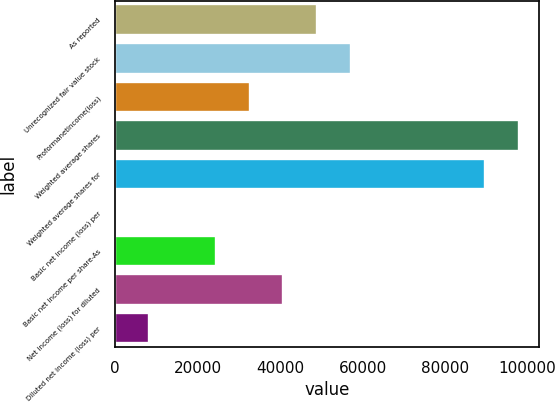Convert chart. <chart><loc_0><loc_0><loc_500><loc_500><bar_chart><fcel>As reported<fcel>Unrecognized fair value stock<fcel>Proformanetincome(loss)<fcel>Weighted average shares<fcel>Weighted average shares for<fcel>Basic net income (loss) per<fcel>Basic net income per share-As<fcel>Net income (loss) for diluted<fcel>Diluted net income (loss) per<nl><fcel>48955.8<fcel>57115.1<fcel>32637.2<fcel>97899.6<fcel>89740.3<fcel>0.09<fcel>24478<fcel>40796.5<fcel>8159.38<nl></chart> 